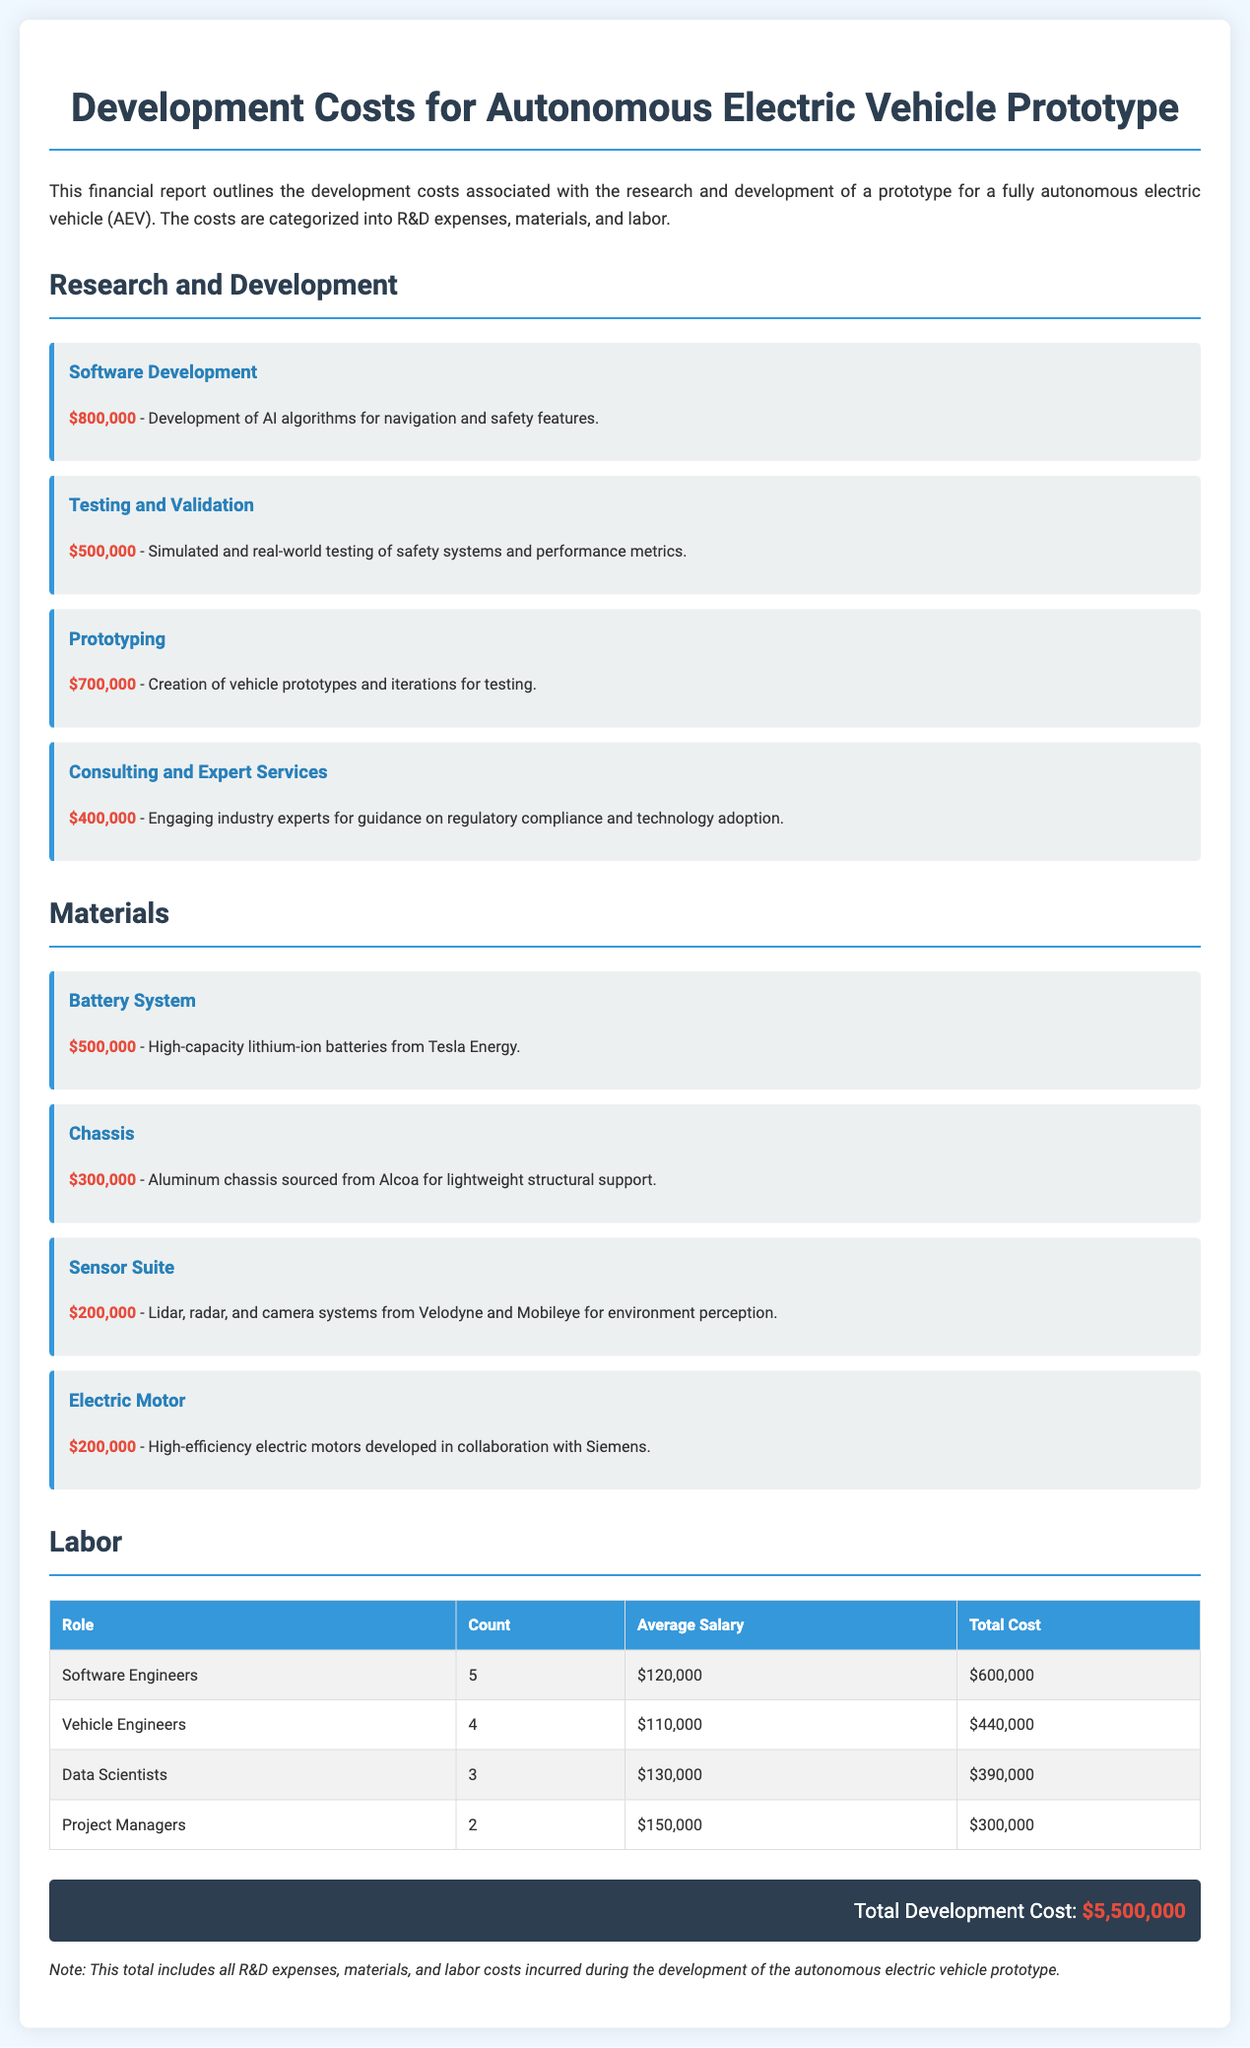What is the total development cost? The total development cost is provided at the bottom of the document, summarizing all expenses.
Answer: $5,500,000 How much was allocated for software development? The document specifies the cost for software development under R&D expenses.
Answer: $800,000 What is the average salary of software engineers? The average salary is mentioned in the labor section of the report.
Answer: $120,000 How many vehicle engineers are there? The count of vehicle engineers is listed in the table detailing labor costs.
Answer: 4 Which material has the highest cost? The document lists various materials and their costs, indicating which one is the highest.
Answer: Battery System What is the total cost for data scientists? The total cost for data scientists is calculated in the labor section.
Answer: $390,000 What category does consulting and expert services fall under? Consulting and expert services are categorized within the R&D expenses section.
Answer: Research and Development What type of batteries is used in the project? The document specifies the type of batteries used for the project in the materials section.
Answer: Lithium-ion batteries Which company provides the battery system? The provider of the battery system is mentioned next to its cost in the materials section.
Answer: Tesla Energy 